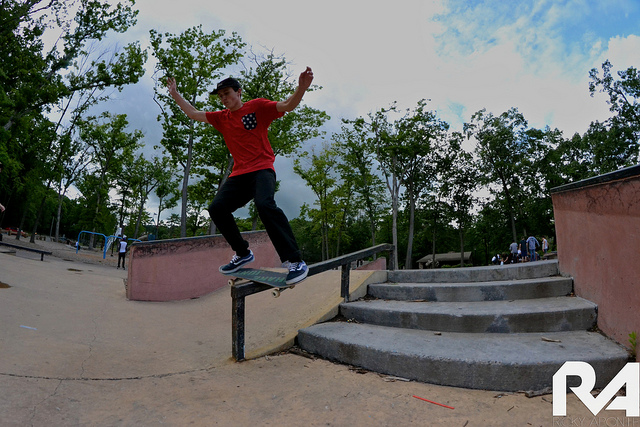Please transcribe the text in this image. RA 